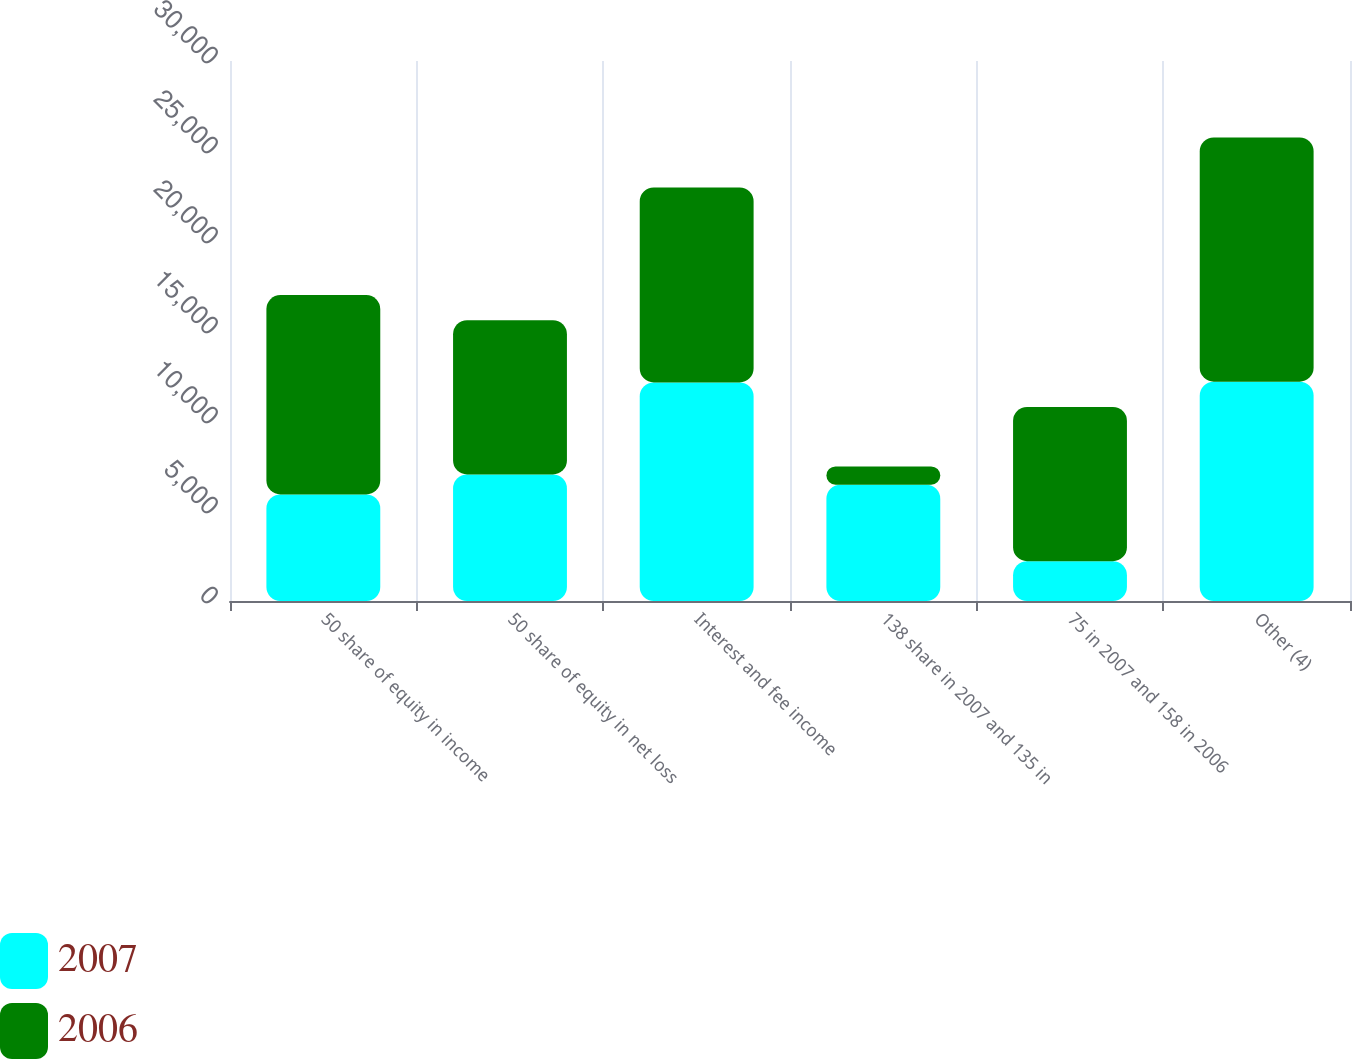<chart> <loc_0><loc_0><loc_500><loc_500><stacked_bar_chart><ecel><fcel>50 share of equity in income<fcel>50 share of equity in net loss<fcel>Interest and fee income<fcel>138 share in 2007 and 135 in<fcel>75 in 2007 and 158 in 2006<fcel>Other (4)<nl><fcel>2007<fcel>5923<fcel>7031<fcel>12141<fcel>6463<fcel>2211<fcel>12184<nl><fcel>2006<fcel>11074<fcel>8567<fcel>10837<fcel>1013<fcel>8567<fcel>13565<nl></chart> 